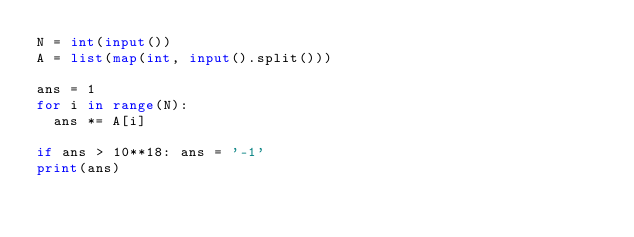<code> <loc_0><loc_0><loc_500><loc_500><_Python_>N = int(input())
A = list(map(int, input().split()))
 
ans = 1
for i in range(N):
  ans *= A[i]

if ans > 10**18: ans = '-1'
print(ans)</code> 